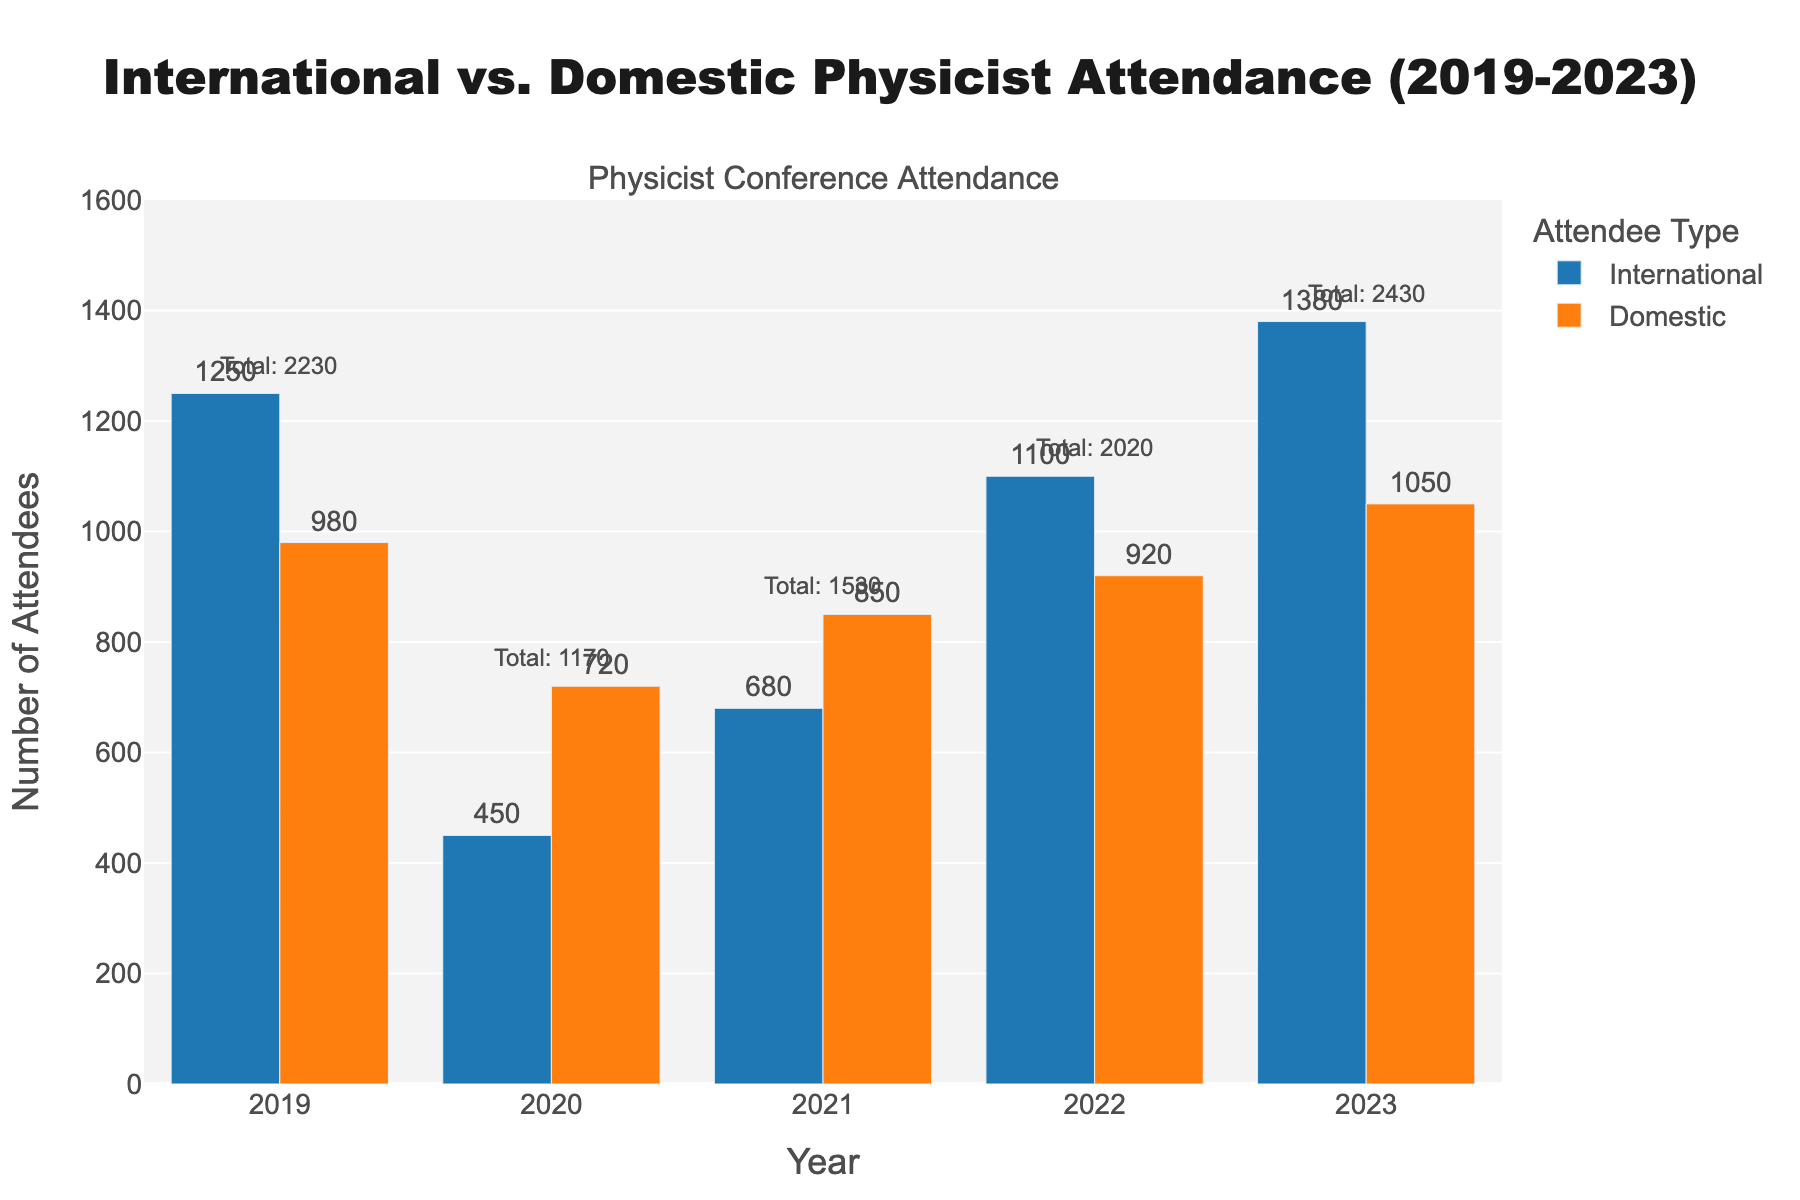What year had the highest number of international attendees? Find the bar with the tallest height for international attendees. The tallest bar is for the year 2023 with 1380 attendees.
Answer: 2023 What is the difference between the number of international and domestic attendees in 2022? Subtract the number of domestic attendees from the international attendees for the year 2022: 1100 - 920 = 180.
Answer: 180 Which year saw the lowest total number of attendees? Add the international and domestic attendees for each year and find the minimum total. 2020 has the lowest total (450 + 720 = 1170).
Answer: 2020 What is the average number of domestic attendees from 2019 to 2023? Sum the domestic attendees for each year and divide by the number of years: (980 + 720 + 850 + 920 + 1050) / 5 = 904.
Answer: 904 In which year did the number of domestic attendees surpass the number of international attendees? Compare the heights of the bars for domestic and international attendance for each year. In 2020, domestic attendees (720) surpassed international attendees (450).
Answer: 2020 What is the total number of attendees for 2023? Sum the number of international and domestic attendees for the year 2023: 1380 + 1050 = 2430.
Answer: 2430 Compare the increase in the number of international attendees from 2021 to 2023. Subtract the number of international attendees in 2021 from the number in 2023: 1380 - 680 = 700.
Answer: 700 Which group of attendees (international or domestic) had more attendees every year? Check the height of each bar for every year. International attendees had more attendees in 2019, 2022, and 2023, whereas domestic had more in 2020.
Answer: International (3 out of 5 years) How did the number of domestic attendees change from 2019 to 2020? Subtract the number of domestic attendees in 2020 from 2019: 980 - 720 = 260 decrease.
Answer: Decreased by 260 What is the combined total number of attendees for all years? Sum the international and domestic attendees across all years: (1250 + 450 + 680 + 1100 + 1380) + (980 + 720 + 850 + 920 + 1050) = 12250.
Answer: 12250 